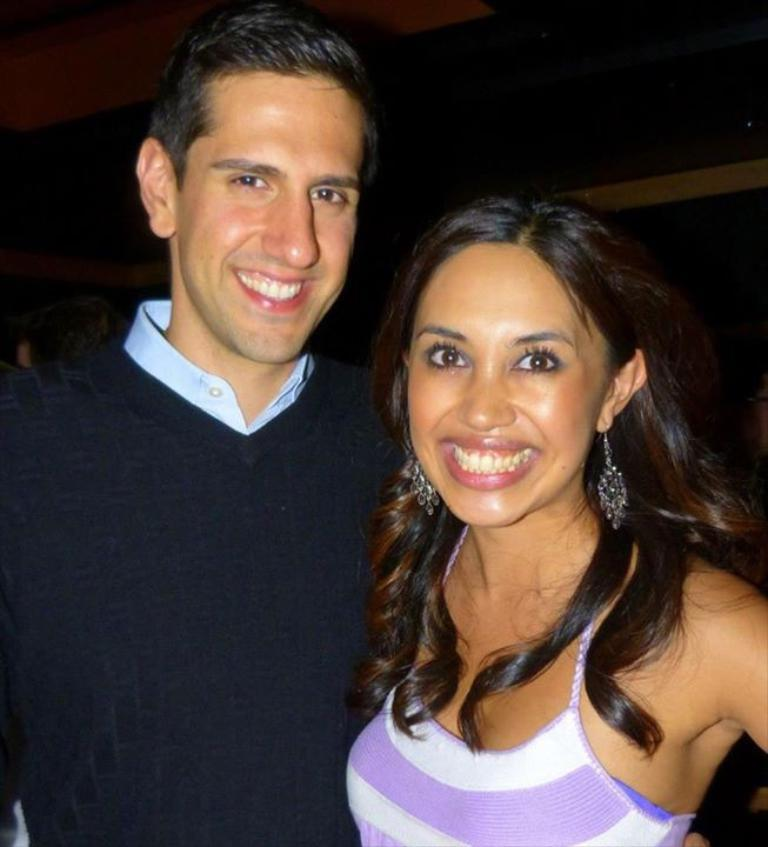How many people are in the image? There are two persons in the image. What can be observed about the attire of the people in the image? Both persons are wearing clothes. What type of building is visible in the image? There is no building present in the image; it only features two persons wearing clothes. What date is marked on the calendar in the image? There is no calendar present in the image. 